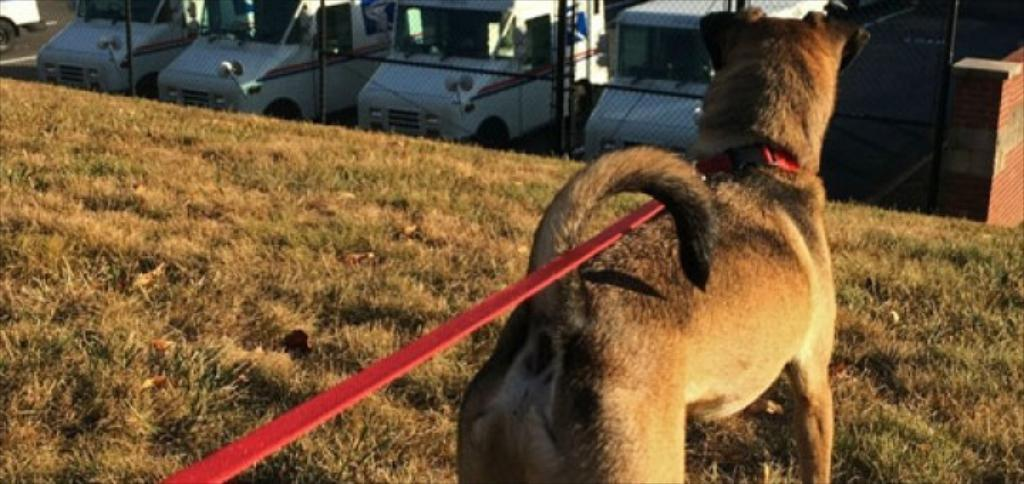What animal can be seen in the image? There is a dog in the image. Where is the dog located in the image? The dog is on the right side of the image. How is the dog secured in the image? The dog is tied with a red color rope. What type of objects can be seen at the top of the image? There are vehicles visible at the top of the image. What additional object is present in the image? There is a net in the image. How many toes does the dog have in the image? Dogs have paws, not toes, and the number of toes or paws cannot be determined from the image. 